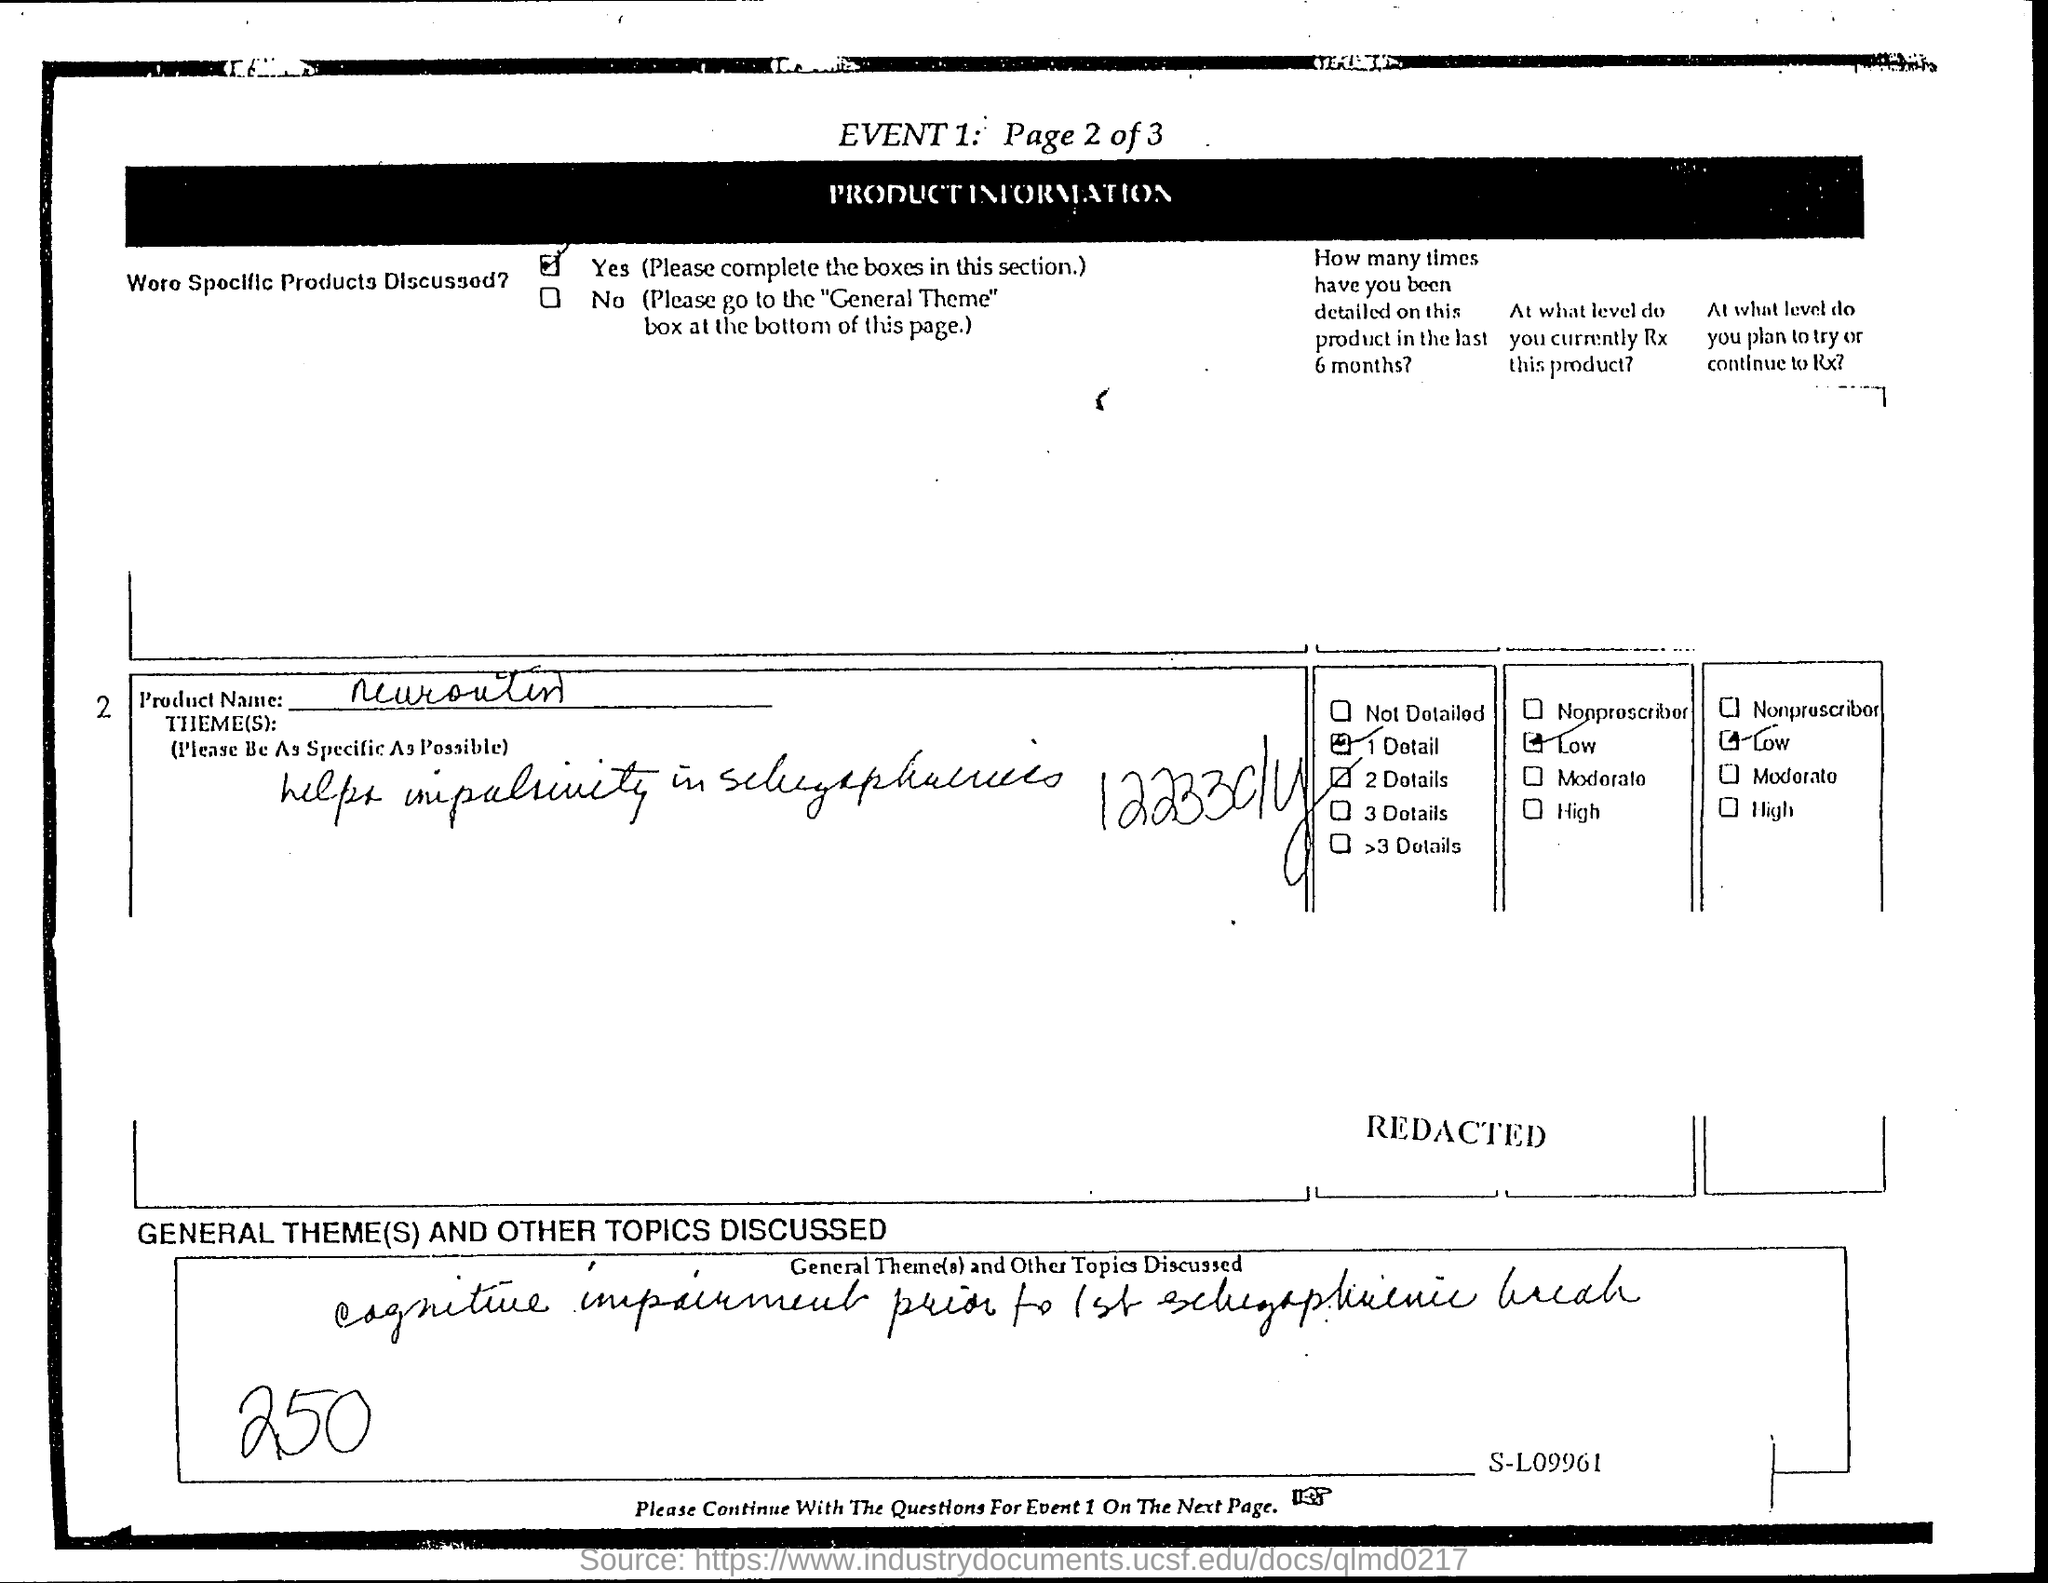What is the Product Name?
Offer a very short reply. Neurontin. 